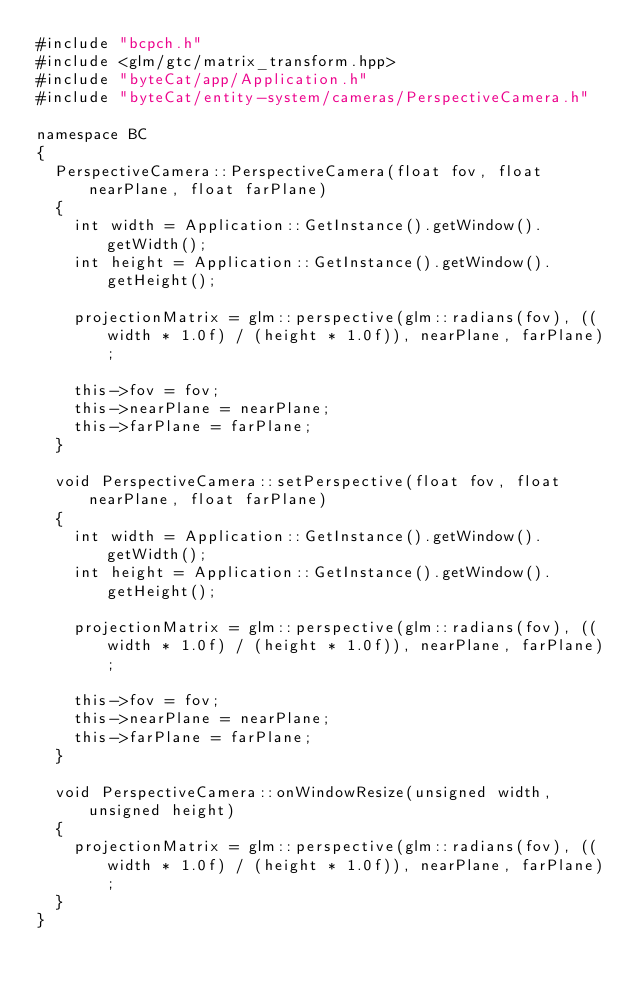<code> <loc_0><loc_0><loc_500><loc_500><_C++_>#include "bcpch.h"
#include <glm/gtc/matrix_transform.hpp>
#include "byteCat/app/Application.h"
#include "byteCat/entity-system/cameras/PerspectiveCamera.h"

namespace BC
{
	PerspectiveCamera::PerspectiveCamera(float fov, float nearPlane, float farPlane)
	{
		int width = Application::GetInstance().getWindow().getWidth();
		int height = Application::GetInstance().getWindow().getHeight();

		projectionMatrix = glm::perspective(glm::radians(fov), ((width * 1.0f) / (height * 1.0f)), nearPlane, farPlane);

		this->fov = fov;
		this->nearPlane = nearPlane;
		this->farPlane = farPlane;
	}

	void PerspectiveCamera::setPerspective(float fov, float nearPlane, float farPlane)
	{
		int width = Application::GetInstance().getWindow().getWidth();
		int height = Application::GetInstance().getWindow().getHeight();

		projectionMatrix = glm::perspective(glm::radians(fov), ((width * 1.0f) / (height * 1.0f)), nearPlane, farPlane);

		this->fov = fov;
		this->nearPlane = nearPlane;
		this->farPlane = farPlane;
	}

	void PerspectiveCamera::onWindowResize(unsigned width, unsigned height)
	{
		projectionMatrix = glm::perspective(glm::radians(fov), ((width * 1.0f) / (height * 1.0f)), nearPlane, farPlane);
	}
}
</code> 